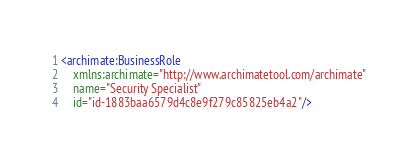Convert code to text. <code><loc_0><loc_0><loc_500><loc_500><_XML_><archimate:BusinessRole
    xmlns:archimate="http://www.archimatetool.com/archimate"
    name="Security Specialist"
    id="id-1883baa6579d4c8e9f279c85825eb4a2"/>
</code> 